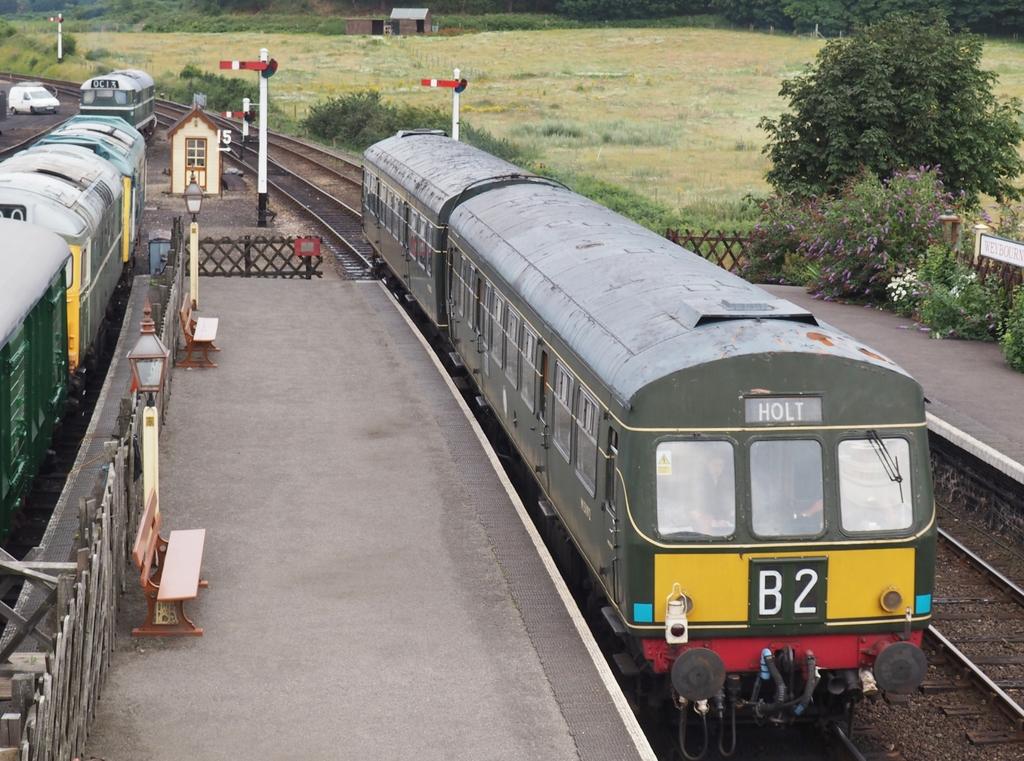What is the train number?
Offer a very short reply. B2. 